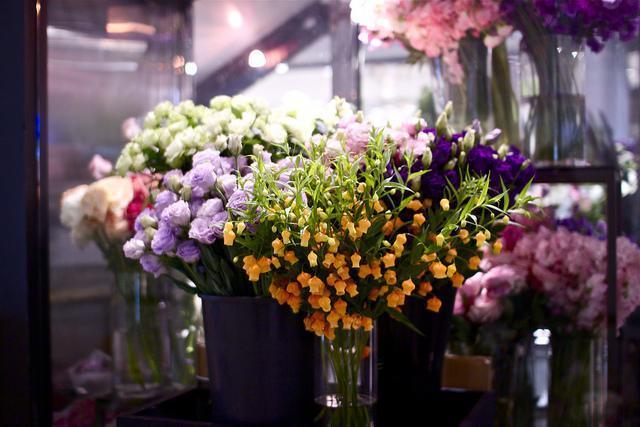How many vases are there?
Give a very brief answer. 7. How many people are wearing hats?
Give a very brief answer. 0. 